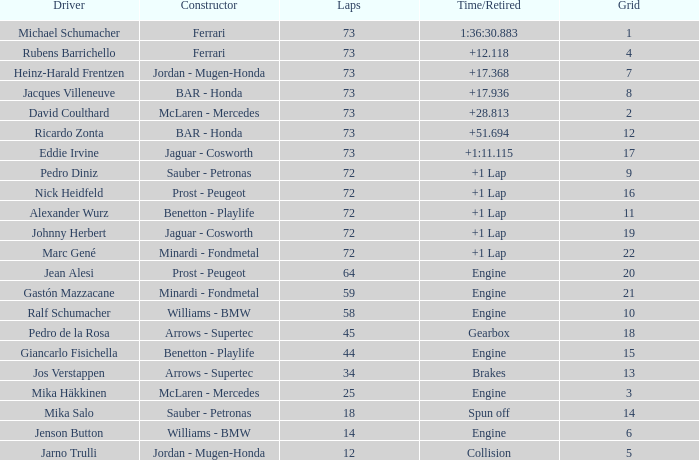How many laps did Giancarlo Fisichella do with a grid larger than 15? 0.0. 